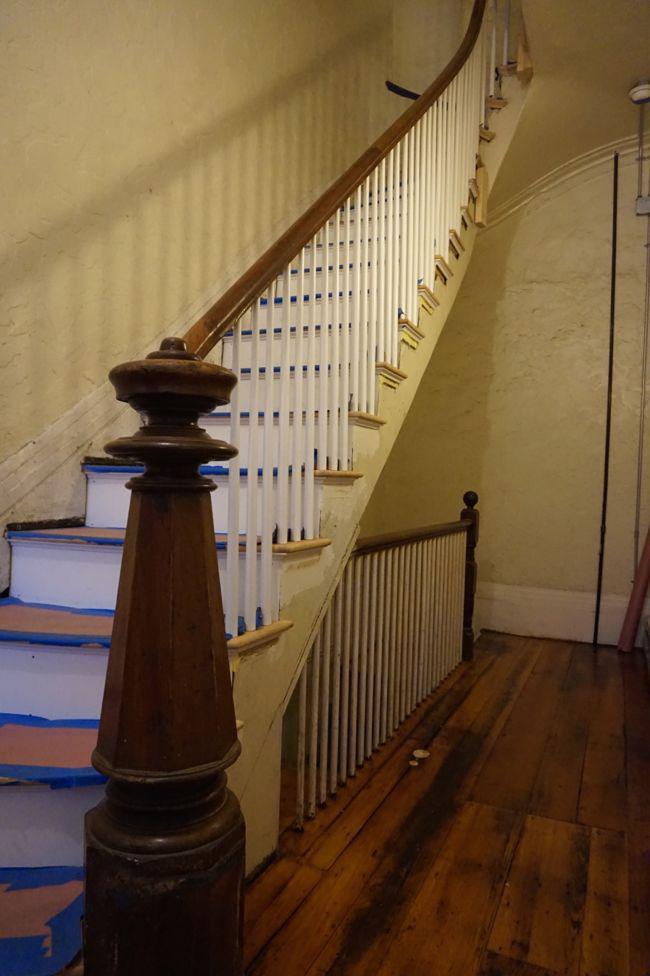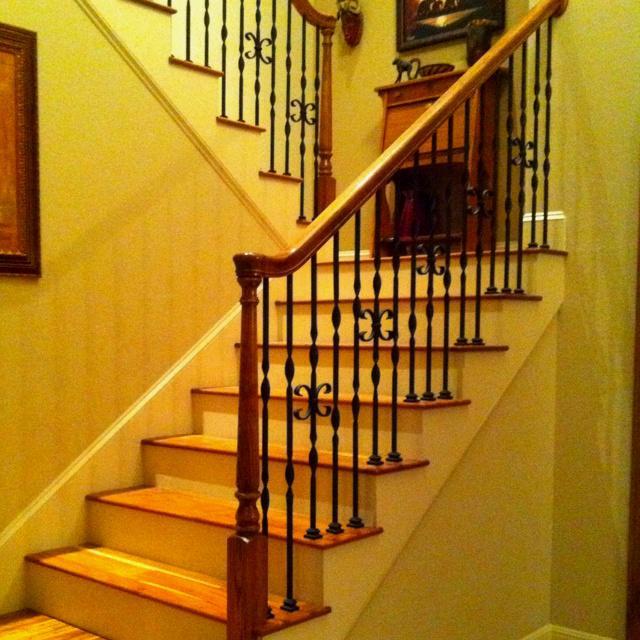The first image is the image on the left, the second image is the image on the right. Given the left and right images, does the statement "One of the stairways curves, while the other stairway has straight sections." hold true? Answer yes or no. Yes. The first image is the image on the left, the second image is the image on the right. Evaluate the accuracy of this statement regarding the images: "Each image features a non-curved staircase with wooden handrails and wrought iron bars that feature some dimensional decorative element.". Is it true? Answer yes or no. No. 